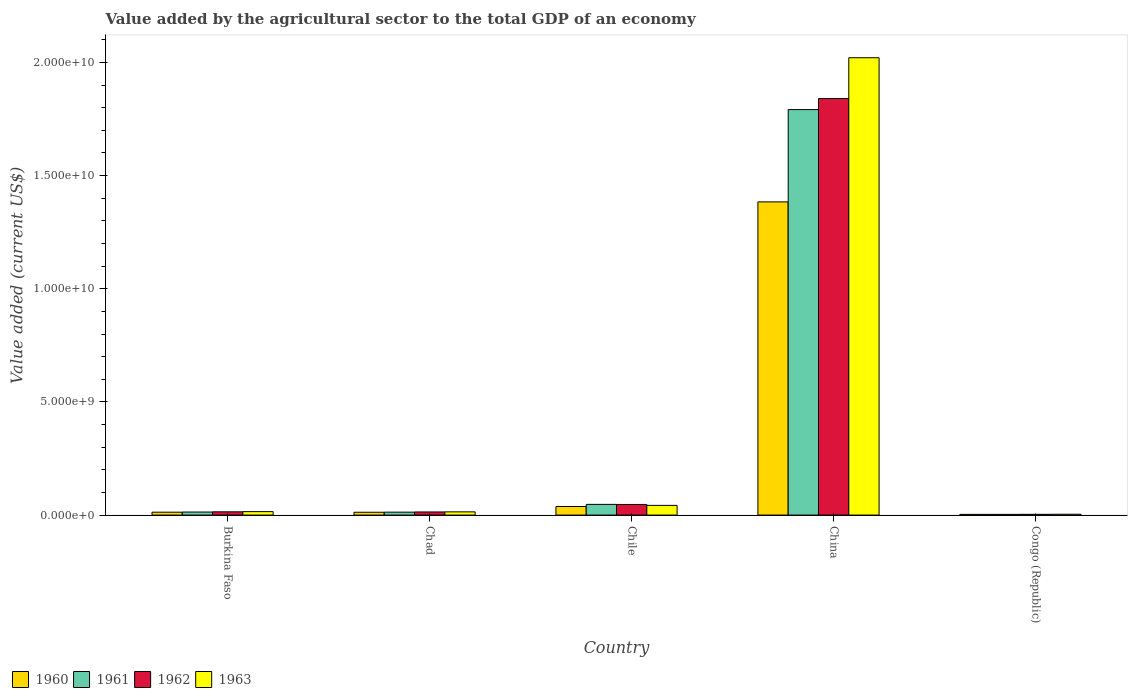How many different coloured bars are there?
Make the answer very short. 4. How many groups of bars are there?
Give a very brief answer. 5. Are the number of bars per tick equal to the number of legend labels?
Your response must be concise. Yes. Are the number of bars on each tick of the X-axis equal?
Offer a terse response. Yes. How many bars are there on the 2nd tick from the left?
Ensure brevity in your answer.  4. How many bars are there on the 1st tick from the right?
Offer a very short reply. 4. What is the value added by the agricultural sector to the total GDP in 1961 in China?
Offer a terse response. 1.79e+1. Across all countries, what is the maximum value added by the agricultural sector to the total GDP in 1962?
Give a very brief answer. 1.84e+1. Across all countries, what is the minimum value added by the agricultural sector to the total GDP in 1963?
Keep it short and to the point. 3.61e+07. In which country was the value added by the agricultural sector to the total GDP in 1961 minimum?
Provide a succinct answer. Congo (Republic). What is the total value added by the agricultural sector to the total GDP in 1961 in the graph?
Make the answer very short. 1.87e+1. What is the difference between the value added by the agricultural sector to the total GDP in 1962 in Burkina Faso and that in China?
Give a very brief answer. -1.83e+1. What is the difference between the value added by the agricultural sector to the total GDP in 1961 in Congo (Republic) and the value added by the agricultural sector to the total GDP in 1960 in Burkina Faso?
Make the answer very short. -9.61e+07. What is the average value added by the agricultural sector to the total GDP in 1960 per country?
Provide a succinct answer. 2.90e+09. What is the difference between the value added by the agricultural sector to the total GDP of/in 1960 and value added by the agricultural sector to the total GDP of/in 1963 in Congo (Republic)?
Offer a very short reply. -5.00e+06. In how many countries, is the value added by the agricultural sector to the total GDP in 1963 greater than 8000000000 US$?
Your answer should be very brief. 1. What is the ratio of the value added by the agricultural sector to the total GDP in 1962 in Burkina Faso to that in Congo (Republic)?
Your response must be concise. 4.36. What is the difference between the highest and the second highest value added by the agricultural sector to the total GDP in 1961?
Provide a succinct answer. 3.38e+08. What is the difference between the highest and the lowest value added by the agricultural sector to the total GDP in 1960?
Make the answer very short. 1.38e+1. Is the sum of the value added by the agricultural sector to the total GDP in 1963 in China and Congo (Republic) greater than the maximum value added by the agricultural sector to the total GDP in 1961 across all countries?
Give a very brief answer. Yes. Is it the case that in every country, the sum of the value added by the agricultural sector to the total GDP in 1962 and value added by the agricultural sector to the total GDP in 1961 is greater than the value added by the agricultural sector to the total GDP in 1960?
Keep it short and to the point. Yes. Are all the bars in the graph horizontal?
Your answer should be compact. No. How many countries are there in the graph?
Your response must be concise. 5. Does the graph contain any zero values?
Your response must be concise. No. How are the legend labels stacked?
Your answer should be compact. Horizontal. What is the title of the graph?
Offer a very short reply. Value added by the agricultural sector to the total GDP of an economy. What is the label or title of the X-axis?
Offer a terse response. Country. What is the label or title of the Y-axis?
Your answer should be very brief. Value added (current US$). What is the Value added (current US$) of 1960 in Burkina Faso?
Keep it short and to the point. 1.27e+08. What is the Value added (current US$) of 1961 in Burkina Faso?
Provide a short and direct response. 1.34e+08. What is the Value added (current US$) in 1962 in Burkina Faso?
Give a very brief answer. 1.44e+08. What is the Value added (current US$) in 1963 in Burkina Faso?
Your response must be concise. 1.52e+08. What is the Value added (current US$) of 1960 in Chad?
Keep it short and to the point. 1.25e+08. What is the Value added (current US$) in 1961 in Chad?
Make the answer very short. 1.29e+08. What is the Value added (current US$) of 1962 in Chad?
Offer a terse response. 1.38e+08. What is the Value added (current US$) of 1963 in Chad?
Keep it short and to the point. 1.41e+08. What is the Value added (current US$) in 1960 in Chile?
Provide a short and direct response. 3.78e+08. What is the Value added (current US$) in 1961 in Chile?
Your response must be concise. 4.72e+08. What is the Value added (current US$) of 1962 in Chile?
Ensure brevity in your answer.  4.69e+08. What is the Value added (current US$) in 1963 in Chile?
Your answer should be very brief. 4.28e+08. What is the Value added (current US$) in 1960 in China?
Provide a succinct answer. 1.38e+1. What is the Value added (current US$) in 1961 in China?
Your answer should be very brief. 1.79e+1. What is the Value added (current US$) of 1962 in China?
Provide a short and direct response. 1.84e+1. What is the Value added (current US$) of 1963 in China?
Provide a succinct answer. 2.02e+1. What is the Value added (current US$) of 1960 in Congo (Republic)?
Your response must be concise. 3.11e+07. What is the Value added (current US$) in 1961 in Congo (Republic)?
Keep it short and to the point. 3.11e+07. What is the Value added (current US$) of 1962 in Congo (Republic)?
Keep it short and to the point. 3.30e+07. What is the Value added (current US$) of 1963 in Congo (Republic)?
Keep it short and to the point. 3.61e+07. Across all countries, what is the maximum Value added (current US$) of 1960?
Keep it short and to the point. 1.38e+1. Across all countries, what is the maximum Value added (current US$) in 1961?
Provide a short and direct response. 1.79e+1. Across all countries, what is the maximum Value added (current US$) of 1962?
Your answer should be compact. 1.84e+1. Across all countries, what is the maximum Value added (current US$) of 1963?
Offer a very short reply. 2.02e+1. Across all countries, what is the minimum Value added (current US$) of 1960?
Your answer should be very brief. 3.11e+07. Across all countries, what is the minimum Value added (current US$) in 1961?
Keep it short and to the point. 3.11e+07. Across all countries, what is the minimum Value added (current US$) in 1962?
Your answer should be compact. 3.30e+07. Across all countries, what is the minimum Value added (current US$) of 1963?
Offer a very short reply. 3.61e+07. What is the total Value added (current US$) of 1960 in the graph?
Your answer should be compact. 1.45e+1. What is the total Value added (current US$) in 1961 in the graph?
Your answer should be compact. 1.87e+1. What is the total Value added (current US$) of 1962 in the graph?
Offer a terse response. 1.92e+1. What is the total Value added (current US$) in 1963 in the graph?
Your answer should be compact. 2.10e+1. What is the difference between the Value added (current US$) in 1960 in Burkina Faso and that in Chad?
Your answer should be very brief. 2.61e+06. What is the difference between the Value added (current US$) in 1961 in Burkina Faso and that in Chad?
Your answer should be compact. 4.79e+06. What is the difference between the Value added (current US$) of 1962 in Burkina Faso and that in Chad?
Your answer should be compact. 6.10e+06. What is the difference between the Value added (current US$) of 1963 in Burkina Faso and that in Chad?
Ensure brevity in your answer.  1.03e+07. What is the difference between the Value added (current US$) in 1960 in Burkina Faso and that in Chile?
Give a very brief answer. -2.51e+08. What is the difference between the Value added (current US$) in 1961 in Burkina Faso and that in Chile?
Keep it short and to the point. -3.38e+08. What is the difference between the Value added (current US$) in 1962 in Burkina Faso and that in Chile?
Ensure brevity in your answer.  -3.25e+08. What is the difference between the Value added (current US$) in 1963 in Burkina Faso and that in Chile?
Offer a terse response. -2.76e+08. What is the difference between the Value added (current US$) of 1960 in Burkina Faso and that in China?
Offer a terse response. -1.37e+1. What is the difference between the Value added (current US$) in 1961 in Burkina Faso and that in China?
Ensure brevity in your answer.  -1.78e+1. What is the difference between the Value added (current US$) of 1962 in Burkina Faso and that in China?
Give a very brief answer. -1.83e+1. What is the difference between the Value added (current US$) in 1963 in Burkina Faso and that in China?
Your answer should be compact. -2.01e+1. What is the difference between the Value added (current US$) in 1960 in Burkina Faso and that in Congo (Republic)?
Your response must be concise. 9.61e+07. What is the difference between the Value added (current US$) of 1961 in Burkina Faso and that in Congo (Republic)?
Make the answer very short. 1.03e+08. What is the difference between the Value added (current US$) of 1962 in Burkina Faso and that in Congo (Republic)?
Your answer should be compact. 1.11e+08. What is the difference between the Value added (current US$) in 1963 in Burkina Faso and that in Congo (Republic)?
Keep it short and to the point. 1.16e+08. What is the difference between the Value added (current US$) of 1960 in Chad and that in Chile?
Offer a terse response. -2.54e+08. What is the difference between the Value added (current US$) in 1961 in Chad and that in Chile?
Provide a short and direct response. -3.43e+08. What is the difference between the Value added (current US$) in 1962 in Chad and that in Chile?
Give a very brief answer. -3.31e+08. What is the difference between the Value added (current US$) of 1963 in Chad and that in Chile?
Make the answer very short. -2.87e+08. What is the difference between the Value added (current US$) of 1960 in Chad and that in China?
Your answer should be very brief. -1.37e+1. What is the difference between the Value added (current US$) in 1961 in Chad and that in China?
Provide a succinct answer. -1.78e+1. What is the difference between the Value added (current US$) of 1962 in Chad and that in China?
Offer a terse response. -1.83e+1. What is the difference between the Value added (current US$) in 1963 in Chad and that in China?
Give a very brief answer. -2.01e+1. What is the difference between the Value added (current US$) of 1960 in Chad and that in Congo (Republic)?
Your answer should be compact. 9.35e+07. What is the difference between the Value added (current US$) of 1961 in Chad and that in Congo (Republic)?
Provide a short and direct response. 9.83e+07. What is the difference between the Value added (current US$) of 1962 in Chad and that in Congo (Republic)?
Keep it short and to the point. 1.05e+08. What is the difference between the Value added (current US$) in 1963 in Chad and that in Congo (Republic)?
Offer a very short reply. 1.05e+08. What is the difference between the Value added (current US$) in 1960 in Chile and that in China?
Your answer should be compact. -1.35e+1. What is the difference between the Value added (current US$) of 1961 in Chile and that in China?
Offer a terse response. -1.74e+1. What is the difference between the Value added (current US$) in 1962 in Chile and that in China?
Ensure brevity in your answer.  -1.79e+1. What is the difference between the Value added (current US$) in 1963 in Chile and that in China?
Your answer should be compact. -1.98e+1. What is the difference between the Value added (current US$) in 1960 in Chile and that in Congo (Republic)?
Provide a succinct answer. 3.47e+08. What is the difference between the Value added (current US$) in 1961 in Chile and that in Congo (Republic)?
Offer a very short reply. 4.41e+08. What is the difference between the Value added (current US$) of 1962 in Chile and that in Congo (Republic)?
Make the answer very short. 4.36e+08. What is the difference between the Value added (current US$) of 1963 in Chile and that in Congo (Republic)?
Make the answer very short. 3.92e+08. What is the difference between the Value added (current US$) of 1960 in China and that in Congo (Republic)?
Offer a terse response. 1.38e+1. What is the difference between the Value added (current US$) in 1961 in China and that in Congo (Republic)?
Your answer should be compact. 1.79e+1. What is the difference between the Value added (current US$) of 1962 in China and that in Congo (Republic)?
Provide a short and direct response. 1.84e+1. What is the difference between the Value added (current US$) of 1963 in China and that in Congo (Republic)?
Your response must be concise. 2.02e+1. What is the difference between the Value added (current US$) in 1960 in Burkina Faso and the Value added (current US$) in 1961 in Chad?
Provide a succinct answer. -2.21e+06. What is the difference between the Value added (current US$) in 1960 in Burkina Faso and the Value added (current US$) in 1962 in Chad?
Keep it short and to the point. -1.04e+07. What is the difference between the Value added (current US$) in 1960 in Burkina Faso and the Value added (current US$) in 1963 in Chad?
Provide a short and direct response. -1.42e+07. What is the difference between the Value added (current US$) in 1961 in Burkina Faso and the Value added (current US$) in 1962 in Chad?
Offer a very short reply. -3.43e+06. What is the difference between the Value added (current US$) in 1961 in Burkina Faso and the Value added (current US$) in 1963 in Chad?
Offer a very short reply. -7.20e+06. What is the difference between the Value added (current US$) of 1962 in Burkina Faso and the Value added (current US$) of 1963 in Chad?
Ensure brevity in your answer.  2.33e+06. What is the difference between the Value added (current US$) in 1960 in Burkina Faso and the Value added (current US$) in 1961 in Chile?
Provide a succinct answer. -3.45e+08. What is the difference between the Value added (current US$) in 1960 in Burkina Faso and the Value added (current US$) in 1962 in Chile?
Your answer should be compact. -3.41e+08. What is the difference between the Value added (current US$) in 1960 in Burkina Faso and the Value added (current US$) in 1963 in Chile?
Offer a very short reply. -3.01e+08. What is the difference between the Value added (current US$) of 1961 in Burkina Faso and the Value added (current US$) of 1962 in Chile?
Provide a short and direct response. -3.34e+08. What is the difference between the Value added (current US$) of 1961 in Burkina Faso and the Value added (current US$) of 1963 in Chile?
Offer a very short reply. -2.94e+08. What is the difference between the Value added (current US$) of 1962 in Burkina Faso and the Value added (current US$) of 1963 in Chile?
Keep it short and to the point. -2.84e+08. What is the difference between the Value added (current US$) in 1960 in Burkina Faso and the Value added (current US$) in 1961 in China?
Make the answer very short. -1.78e+1. What is the difference between the Value added (current US$) of 1960 in Burkina Faso and the Value added (current US$) of 1962 in China?
Keep it short and to the point. -1.83e+1. What is the difference between the Value added (current US$) in 1960 in Burkina Faso and the Value added (current US$) in 1963 in China?
Your answer should be compact. -2.01e+1. What is the difference between the Value added (current US$) of 1961 in Burkina Faso and the Value added (current US$) of 1962 in China?
Your answer should be compact. -1.83e+1. What is the difference between the Value added (current US$) of 1961 in Burkina Faso and the Value added (current US$) of 1963 in China?
Make the answer very short. -2.01e+1. What is the difference between the Value added (current US$) in 1962 in Burkina Faso and the Value added (current US$) in 1963 in China?
Ensure brevity in your answer.  -2.01e+1. What is the difference between the Value added (current US$) of 1960 in Burkina Faso and the Value added (current US$) of 1961 in Congo (Republic)?
Keep it short and to the point. 9.61e+07. What is the difference between the Value added (current US$) of 1960 in Burkina Faso and the Value added (current US$) of 1962 in Congo (Republic)?
Offer a terse response. 9.42e+07. What is the difference between the Value added (current US$) of 1960 in Burkina Faso and the Value added (current US$) of 1963 in Congo (Republic)?
Offer a very short reply. 9.11e+07. What is the difference between the Value added (current US$) of 1961 in Burkina Faso and the Value added (current US$) of 1962 in Congo (Republic)?
Offer a terse response. 1.01e+08. What is the difference between the Value added (current US$) of 1961 in Burkina Faso and the Value added (current US$) of 1963 in Congo (Republic)?
Keep it short and to the point. 9.81e+07. What is the difference between the Value added (current US$) in 1962 in Burkina Faso and the Value added (current US$) in 1963 in Congo (Republic)?
Give a very brief answer. 1.08e+08. What is the difference between the Value added (current US$) of 1960 in Chad and the Value added (current US$) of 1961 in Chile?
Provide a succinct answer. -3.48e+08. What is the difference between the Value added (current US$) of 1960 in Chad and the Value added (current US$) of 1962 in Chile?
Keep it short and to the point. -3.44e+08. What is the difference between the Value added (current US$) of 1960 in Chad and the Value added (current US$) of 1963 in Chile?
Keep it short and to the point. -3.03e+08. What is the difference between the Value added (current US$) of 1961 in Chad and the Value added (current US$) of 1962 in Chile?
Provide a succinct answer. -3.39e+08. What is the difference between the Value added (current US$) of 1961 in Chad and the Value added (current US$) of 1963 in Chile?
Offer a very short reply. -2.99e+08. What is the difference between the Value added (current US$) in 1962 in Chad and the Value added (current US$) in 1963 in Chile?
Your response must be concise. -2.90e+08. What is the difference between the Value added (current US$) of 1960 in Chad and the Value added (current US$) of 1961 in China?
Provide a short and direct response. -1.78e+1. What is the difference between the Value added (current US$) in 1960 in Chad and the Value added (current US$) in 1962 in China?
Provide a succinct answer. -1.83e+1. What is the difference between the Value added (current US$) of 1960 in Chad and the Value added (current US$) of 1963 in China?
Provide a succinct answer. -2.01e+1. What is the difference between the Value added (current US$) in 1961 in Chad and the Value added (current US$) in 1962 in China?
Keep it short and to the point. -1.83e+1. What is the difference between the Value added (current US$) in 1961 in Chad and the Value added (current US$) in 1963 in China?
Offer a terse response. -2.01e+1. What is the difference between the Value added (current US$) of 1962 in Chad and the Value added (current US$) of 1963 in China?
Ensure brevity in your answer.  -2.01e+1. What is the difference between the Value added (current US$) of 1960 in Chad and the Value added (current US$) of 1961 in Congo (Republic)?
Offer a very short reply. 9.35e+07. What is the difference between the Value added (current US$) of 1960 in Chad and the Value added (current US$) of 1962 in Congo (Republic)?
Your answer should be very brief. 9.16e+07. What is the difference between the Value added (current US$) in 1960 in Chad and the Value added (current US$) in 1963 in Congo (Republic)?
Your answer should be very brief. 8.85e+07. What is the difference between the Value added (current US$) in 1961 in Chad and the Value added (current US$) in 1962 in Congo (Republic)?
Keep it short and to the point. 9.64e+07. What is the difference between the Value added (current US$) in 1961 in Chad and the Value added (current US$) in 1963 in Congo (Republic)?
Your answer should be very brief. 9.33e+07. What is the difference between the Value added (current US$) in 1962 in Chad and the Value added (current US$) in 1963 in Congo (Republic)?
Your answer should be compact. 1.02e+08. What is the difference between the Value added (current US$) of 1960 in Chile and the Value added (current US$) of 1961 in China?
Your answer should be very brief. -1.75e+1. What is the difference between the Value added (current US$) in 1960 in Chile and the Value added (current US$) in 1962 in China?
Your answer should be compact. -1.80e+1. What is the difference between the Value added (current US$) of 1960 in Chile and the Value added (current US$) of 1963 in China?
Offer a very short reply. -1.98e+1. What is the difference between the Value added (current US$) in 1961 in Chile and the Value added (current US$) in 1962 in China?
Offer a terse response. -1.79e+1. What is the difference between the Value added (current US$) of 1961 in Chile and the Value added (current US$) of 1963 in China?
Your answer should be compact. -1.97e+1. What is the difference between the Value added (current US$) of 1962 in Chile and the Value added (current US$) of 1963 in China?
Give a very brief answer. -1.97e+1. What is the difference between the Value added (current US$) in 1960 in Chile and the Value added (current US$) in 1961 in Congo (Republic)?
Your answer should be compact. 3.47e+08. What is the difference between the Value added (current US$) of 1960 in Chile and the Value added (current US$) of 1962 in Congo (Republic)?
Ensure brevity in your answer.  3.45e+08. What is the difference between the Value added (current US$) of 1960 in Chile and the Value added (current US$) of 1963 in Congo (Republic)?
Provide a short and direct response. 3.42e+08. What is the difference between the Value added (current US$) of 1961 in Chile and the Value added (current US$) of 1962 in Congo (Republic)?
Ensure brevity in your answer.  4.39e+08. What is the difference between the Value added (current US$) in 1961 in Chile and the Value added (current US$) in 1963 in Congo (Republic)?
Offer a very short reply. 4.36e+08. What is the difference between the Value added (current US$) of 1962 in Chile and the Value added (current US$) of 1963 in Congo (Republic)?
Ensure brevity in your answer.  4.33e+08. What is the difference between the Value added (current US$) in 1960 in China and the Value added (current US$) in 1961 in Congo (Republic)?
Ensure brevity in your answer.  1.38e+1. What is the difference between the Value added (current US$) of 1960 in China and the Value added (current US$) of 1962 in Congo (Republic)?
Your answer should be very brief. 1.38e+1. What is the difference between the Value added (current US$) of 1960 in China and the Value added (current US$) of 1963 in Congo (Republic)?
Offer a terse response. 1.38e+1. What is the difference between the Value added (current US$) of 1961 in China and the Value added (current US$) of 1962 in Congo (Republic)?
Keep it short and to the point. 1.79e+1. What is the difference between the Value added (current US$) in 1961 in China and the Value added (current US$) in 1963 in Congo (Republic)?
Your response must be concise. 1.79e+1. What is the difference between the Value added (current US$) in 1962 in China and the Value added (current US$) in 1963 in Congo (Republic)?
Make the answer very short. 1.84e+1. What is the average Value added (current US$) in 1960 per country?
Provide a short and direct response. 2.90e+09. What is the average Value added (current US$) in 1961 per country?
Make the answer very short. 3.74e+09. What is the average Value added (current US$) of 1962 per country?
Offer a very short reply. 3.84e+09. What is the average Value added (current US$) in 1963 per country?
Offer a very short reply. 4.19e+09. What is the difference between the Value added (current US$) of 1960 and Value added (current US$) of 1961 in Burkina Faso?
Your answer should be very brief. -7.00e+06. What is the difference between the Value added (current US$) in 1960 and Value added (current US$) in 1962 in Burkina Faso?
Offer a terse response. -1.65e+07. What is the difference between the Value added (current US$) of 1960 and Value added (current US$) of 1963 in Burkina Faso?
Provide a succinct answer. -2.45e+07. What is the difference between the Value added (current US$) of 1961 and Value added (current US$) of 1962 in Burkina Faso?
Your answer should be very brief. -9.53e+06. What is the difference between the Value added (current US$) in 1961 and Value added (current US$) in 1963 in Burkina Faso?
Offer a very short reply. -1.75e+07. What is the difference between the Value added (current US$) of 1962 and Value added (current US$) of 1963 in Burkina Faso?
Ensure brevity in your answer.  -7.98e+06. What is the difference between the Value added (current US$) of 1960 and Value added (current US$) of 1961 in Chad?
Provide a succinct answer. -4.82e+06. What is the difference between the Value added (current US$) of 1960 and Value added (current US$) of 1962 in Chad?
Ensure brevity in your answer.  -1.30e+07. What is the difference between the Value added (current US$) of 1960 and Value added (current US$) of 1963 in Chad?
Offer a terse response. -1.68e+07. What is the difference between the Value added (current US$) of 1961 and Value added (current US$) of 1962 in Chad?
Give a very brief answer. -8.22e+06. What is the difference between the Value added (current US$) of 1961 and Value added (current US$) of 1963 in Chad?
Offer a terse response. -1.20e+07. What is the difference between the Value added (current US$) in 1962 and Value added (current US$) in 1963 in Chad?
Your answer should be compact. -3.78e+06. What is the difference between the Value added (current US$) in 1960 and Value added (current US$) in 1961 in Chile?
Ensure brevity in your answer.  -9.41e+07. What is the difference between the Value added (current US$) of 1960 and Value added (current US$) of 1962 in Chile?
Give a very brief answer. -9.05e+07. What is the difference between the Value added (current US$) of 1960 and Value added (current US$) of 1963 in Chile?
Your answer should be very brief. -4.98e+07. What is the difference between the Value added (current US$) in 1961 and Value added (current US$) in 1962 in Chile?
Make the answer very short. 3.57e+06. What is the difference between the Value added (current US$) of 1961 and Value added (current US$) of 1963 in Chile?
Offer a terse response. 4.42e+07. What is the difference between the Value added (current US$) in 1962 and Value added (current US$) in 1963 in Chile?
Offer a very short reply. 4.07e+07. What is the difference between the Value added (current US$) of 1960 and Value added (current US$) of 1961 in China?
Your response must be concise. -4.08e+09. What is the difference between the Value added (current US$) of 1960 and Value added (current US$) of 1962 in China?
Give a very brief answer. -4.57e+09. What is the difference between the Value added (current US$) in 1960 and Value added (current US$) in 1963 in China?
Offer a terse response. -6.37e+09. What is the difference between the Value added (current US$) of 1961 and Value added (current US$) of 1962 in China?
Keep it short and to the point. -4.87e+08. What is the difference between the Value added (current US$) in 1961 and Value added (current US$) in 1963 in China?
Ensure brevity in your answer.  -2.29e+09. What is the difference between the Value added (current US$) of 1962 and Value added (current US$) of 1963 in China?
Offer a terse response. -1.80e+09. What is the difference between the Value added (current US$) in 1960 and Value added (current US$) in 1961 in Congo (Republic)?
Keep it short and to the point. 8239.47. What is the difference between the Value added (current US$) of 1960 and Value added (current US$) of 1962 in Congo (Republic)?
Give a very brief answer. -1.89e+06. What is the difference between the Value added (current US$) in 1960 and Value added (current US$) in 1963 in Congo (Republic)?
Give a very brief answer. -5.00e+06. What is the difference between the Value added (current US$) of 1961 and Value added (current US$) of 1962 in Congo (Republic)?
Keep it short and to the point. -1.90e+06. What is the difference between the Value added (current US$) in 1961 and Value added (current US$) in 1963 in Congo (Republic)?
Make the answer very short. -5.01e+06. What is the difference between the Value added (current US$) in 1962 and Value added (current US$) in 1963 in Congo (Republic)?
Your answer should be compact. -3.11e+06. What is the ratio of the Value added (current US$) in 1961 in Burkina Faso to that in Chad?
Ensure brevity in your answer.  1.04. What is the ratio of the Value added (current US$) of 1962 in Burkina Faso to that in Chad?
Offer a terse response. 1.04. What is the ratio of the Value added (current US$) in 1963 in Burkina Faso to that in Chad?
Make the answer very short. 1.07. What is the ratio of the Value added (current US$) of 1960 in Burkina Faso to that in Chile?
Your answer should be compact. 0.34. What is the ratio of the Value added (current US$) in 1961 in Burkina Faso to that in Chile?
Your answer should be very brief. 0.28. What is the ratio of the Value added (current US$) of 1962 in Burkina Faso to that in Chile?
Keep it short and to the point. 0.31. What is the ratio of the Value added (current US$) in 1963 in Burkina Faso to that in Chile?
Your answer should be very brief. 0.35. What is the ratio of the Value added (current US$) of 1960 in Burkina Faso to that in China?
Your response must be concise. 0.01. What is the ratio of the Value added (current US$) of 1961 in Burkina Faso to that in China?
Your response must be concise. 0.01. What is the ratio of the Value added (current US$) of 1962 in Burkina Faso to that in China?
Your answer should be compact. 0.01. What is the ratio of the Value added (current US$) of 1963 in Burkina Faso to that in China?
Offer a very short reply. 0.01. What is the ratio of the Value added (current US$) of 1960 in Burkina Faso to that in Congo (Republic)?
Keep it short and to the point. 4.09. What is the ratio of the Value added (current US$) in 1961 in Burkina Faso to that in Congo (Republic)?
Make the answer very short. 4.32. What is the ratio of the Value added (current US$) of 1962 in Burkina Faso to that in Congo (Republic)?
Make the answer very short. 4.36. What is the ratio of the Value added (current US$) in 1963 in Burkina Faso to that in Congo (Republic)?
Provide a short and direct response. 4.2. What is the ratio of the Value added (current US$) in 1960 in Chad to that in Chile?
Offer a terse response. 0.33. What is the ratio of the Value added (current US$) in 1961 in Chad to that in Chile?
Your answer should be very brief. 0.27. What is the ratio of the Value added (current US$) of 1962 in Chad to that in Chile?
Give a very brief answer. 0.29. What is the ratio of the Value added (current US$) in 1963 in Chad to that in Chile?
Provide a succinct answer. 0.33. What is the ratio of the Value added (current US$) of 1960 in Chad to that in China?
Provide a succinct answer. 0.01. What is the ratio of the Value added (current US$) in 1961 in Chad to that in China?
Offer a very short reply. 0.01. What is the ratio of the Value added (current US$) in 1962 in Chad to that in China?
Keep it short and to the point. 0.01. What is the ratio of the Value added (current US$) in 1963 in Chad to that in China?
Your answer should be very brief. 0.01. What is the ratio of the Value added (current US$) of 1960 in Chad to that in Congo (Republic)?
Give a very brief answer. 4.01. What is the ratio of the Value added (current US$) of 1961 in Chad to that in Congo (Republic)?
Offer a very short reply. 4.16. What is the ratio of the Value added (current US$) in 1962 in Chad to that in Congo (Republic)?
Make the answer very short. 4.17. What is the ratio of the Value added (current US$) in 1963 in Chad to that in Congo (Republic)?
Your answer should be very brief. 3.92. What is the ratio of the Value added (current US$) in 1960 in Chile to that in China?
Ensure brevity in your answer.  0.03. What is the ratio of the Value added (current US$) in 1961 in Chile to that in China?
Your answer should be very brief. 0.03. What is the ratio of the Value added (current US$) of 1962 in Chile to that in China?
Make the answer very short. 0.03. What is the ratio of the Value added (current US$) in 1963 in Chile to that in China?
Offer a terse response. 0.02. What is the ratio of the Value added (current US$) of 1960 in Chile to that in Congo (Republic)?
Keep it short and to the point. 12.16. What is the ratio of the Value added (current US$) in 1961 in Chile to that in Congo (Republic)?
Provide a short and direct response. 15.19. What is the ratio of the Value added (current US$) in 1962 in Chile to that in Congo (Republic)?
Your answer should be very brief. 14.21. What is the ratio of the Value added (current US$) of 1963 in Chile to that in Congo (Republic)?
Offer a very short reply. 11.86. What is the ratio of the Value added (current US$) in 1960 in China to that in Congo (Republic)?
Provide a short and direct response. 445.15. What is the ratio of the Value added (current US$) of 1961 in China to that in Congo (Republic)?
Provide a succinct answer. 576.48. What is the ratio of the Value added (current US$) in 1962 in China to that in Congo (Republic)?
Offer a very short reply. 558.09. What is the ratio of the Value added (current US$) of 1963 in China to that in Congo (Republic)?
Your answer should be very brief. 559.95. What is the difference between the highest and the second highest Value added (current US$) of 1960?
Offer a very short reply. 1.35e+1. What is the difference between the highest and the second highest Value added (current US$) of 1961?
Provide a succinct answer. 1.74e+1. What is the difference between the highest and the second highest Value added (current US$) of 1962?
Ensure brevity in your answer.  1.79e+1. What is the difference between the highest and the second highest Value added (current US$) in 1963?
Your answer should be compact. 1.98e+1. What is the difference between the highest and the lowest Value added (current US$) in 1960?
Your answer should be very brief. 1.38e+1. What is the difference between the highest and the lowest Value added (current US$) of 1961?
Offer a terse response. 1.79e+1. What is the difference between the highest and the lowest Value added (current US$) in 1962?
Keep it short and to the point. 1.84e+1. What is the difference between the highest and the lowest Value added (current US$) of 1963?
Provide a succinct answer. 2.02e+1. 